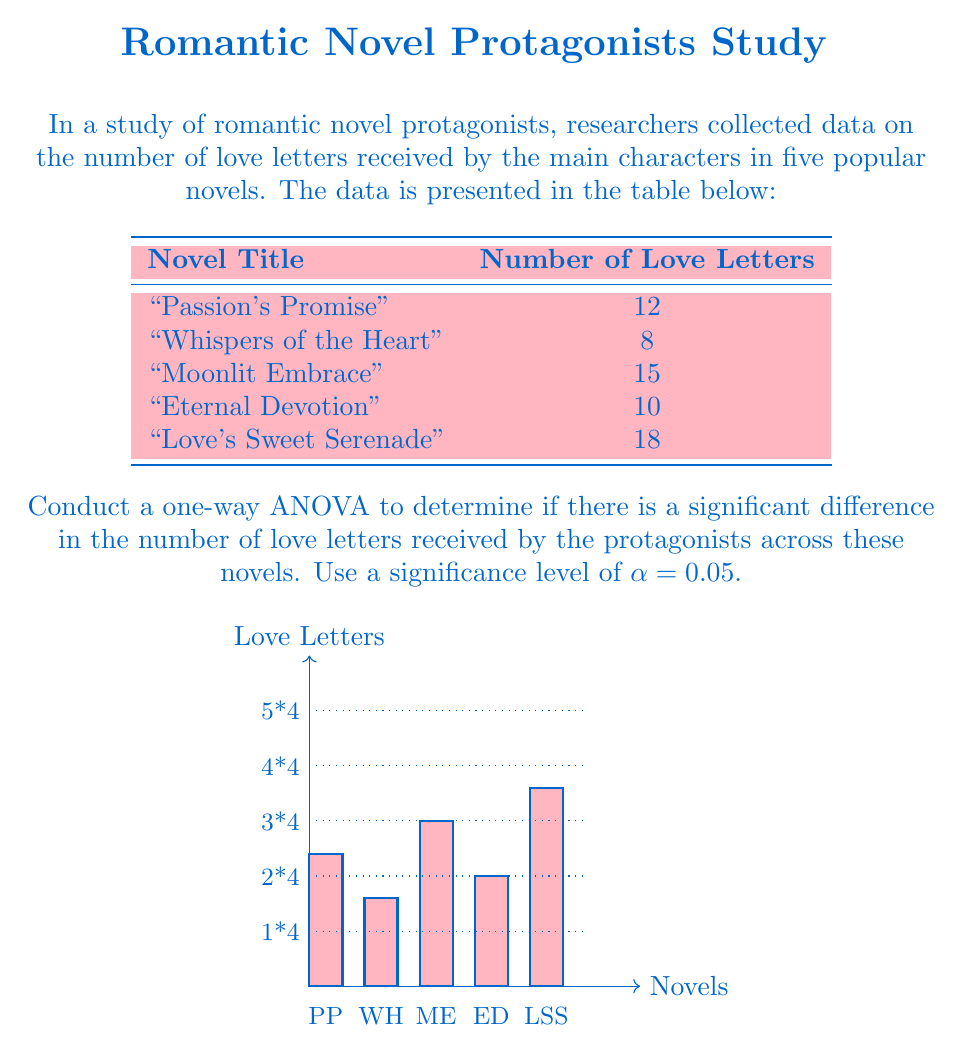Can you answer this question? Let's approach this step-by-step:

1) First, we need to calculate the following:
   - Grand mean
   - Sum of squares total (SST)
   - Sum of squares between (SSB)
   - Sum of squares within (SSW)
   - Degrees of freedom
   - Mean square between (MSB)
   - Mean square within (MSW)
   - F-statistic

2) Grand mean:
   $\bar{X} = \frac{12 + 8 + 15 + 10 + 18}{5} = 12.6$

3) Sum of squares total (SST):
   $SST = \sum(X_i - \bar{X})^2 = (12-12.6)^2 + (8-12.6)^2 + (15-12.6)^2 + (10-12.6)^2 + (18-12.6)^2 = 76.8$

4) Sum of squares between (SSB):
   $SSB = n\sum(\bar{X_i} - \bar{X})^2$, where n = 1 (one observation per group)
   $SSB = 1[(12-12.6)^2 + (8-12.6)^2 + (15-12.6)^2 + (10-12.6)^2 + (18-12.6)^2] = 76.8$

5) Sum of squares within (SSW):
   $SSW = SST - SSB = 76.8 - 76.8 = 0$

6) Degrees of freedom:
   - Between groups: $df_B = k - 1 = 5 - 1 = 4$ (where k is the number of groups)
   - Within groups: $df_W = N - k = 5 - 5 = 0$ (where N is the total number of observations)

7) Mean square between (MSB):
   $MSB = \frac{SSB}{df_B} = \frac{76.8}{4} = 19.2$

8) Mean square within (MSW):
   $MSW = \frac{SSW}{df_W} = \frac{0}{0}$ (undefined)

9) F-statistic:
   $F = \frac{MSB}{MSW}$ (undefined due to division by zero)

In this case, we cannot calculate the F-statistic because MSW is undefined (division by zero). This is because we have only one observation per group, resulting in zero degrees of freedom within groups.

10) Conclusion:
    With only one observation per group, we cannot perform a one-way ANOVA. We need more than one observation per group to calculate within-group variance and conduct the analysis.
Answer: ANOVA cannot be performed due to insufficient data (only one observation per group). 